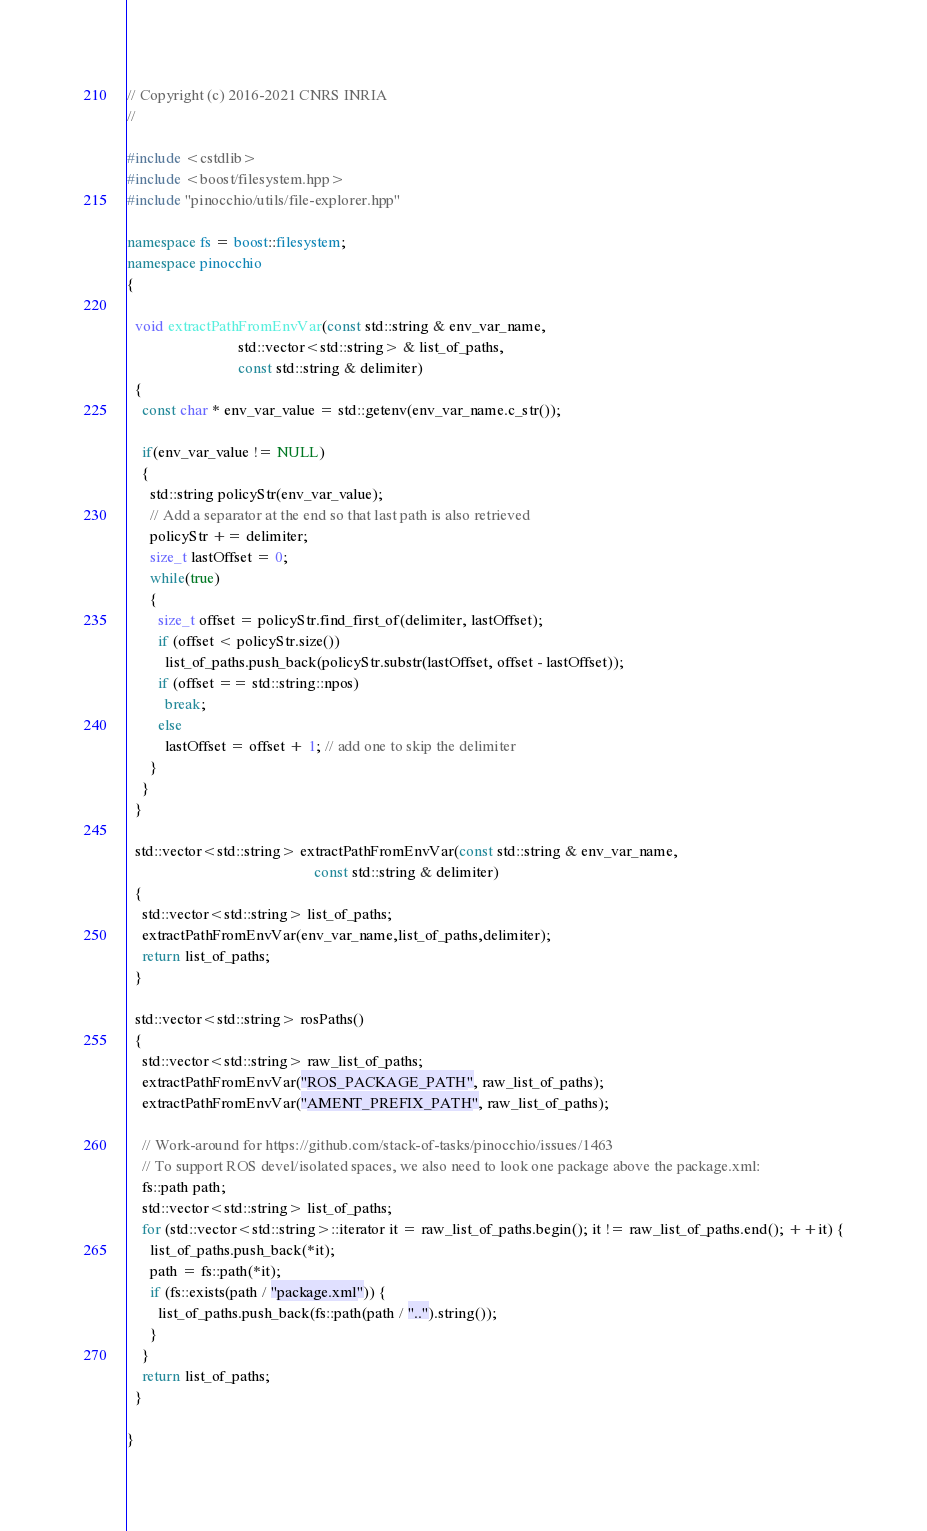Convert code to text. <code><loc_0><loc_0><loc_500><loc_500><_C++_>// Copyright (c) 2016-2021 CNRS INRIA
//

#include <cstdlib>
#include <boost/filesystem.hpp>
#include "pinocchio/utils/file-explorer.hpp"

namespace fs = boost::filesystem;
namespace pinocchio
{

  void extractPathFromEnvVar(const std::string & env_var_name,
                             std::vector<std::string> & list_of_paths,
                             const std::string & delimiter)
  {
    const char * env_var_value = std::getenv(env_var_name.c_str());
    
    if(env_var_value != NULL)
    {
      std::string policyStr(env_var_value);
      // Add a separator at the end so that last path is also retrieved
      policyStr += delimiter;
      size_t lastOffset = 0;
      while(true)
      {
        size_t offset = policyStr.find_first_of(delimiter, lastOffset);
        if (offset < policyStr.size())
          list_of_paths.push_back(policyStr.substr(lastOffset, offset - lastOffset));
        if (offset == std::string::npos)
          break;
        else
          lastOffset = offset + 1; // add one to skip the delimiter
      }
    }
  }

  std::vector<std::string> extractPathFromEnvVar(const std::string & env_var_name,
                                                 const std::string & delimiter)
  {
    std::vector<std::string> list_of_paths;
    extractPathFromEnvVar(env_var_name,list_of_paths,delimiter);
    return list_of_paths;
  }

  std::vector<std::string> rosPaths()
  {
    std::vector<std::string> raw_list_of_paths;
    extractPathFromEnvVar("ROS_PACKAGE_PATH", raw_list_of_paths);
    extractPathFromEnvVar("AMENT_PREFIX_PATH", raw_list_of_paths);

    // Work-around for https://github.com/stack-of-tasks/pinocchio/issues/1463
    // To support ROS devel/isolated spaces, we also need to look one package above the package.xml:
    fs::path path;
    std::vector<std::string> list_of_paths;
    for (std::vector<std::string>::iterator it = raw_list_of_paths.begin(); it != raw_list_of_paths.end(); ++it) {
      list_of_paths.push_back(*it);
      path = fs::path(*it);
      if (fs::exists(path / "package.xml")) {
        list_of_paths.push_back(fs::path(path / "..").string());
      }
    }
    return list_of_paths;
  }

}
</code> 